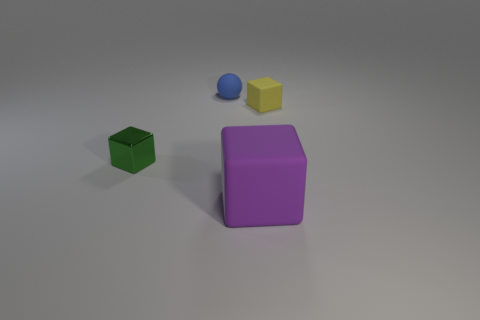There is a small thing in front of the yellow block; is there a tiny green shiny thing left of it?
Your answer should be very brief. No. What number of matte objects are either small objects or blue balls?
Ensure brevity in your answer.  2. The object that is in front of the rubber ball and behind the small green cube is made of what material?
Your response must be concise. Rubber. There is a tiny object that is in front of the block behind the metal cube; is there a big purple rubber block behind it?
Offer a very short reply. No. Are there any other things that have the same material as the purple cube?
Your response must be concise. Yes. The yellow object that is made of the same material as the large cube is what shape?
Provide a short and direct response. Cube. Is the number of tiny spheres that are behind the blue thing less than the number of large purple rubber things that are right of the large purple block?
Offer a terse response. No. How many tiny things are either blue things or yellow rubber blocks?
Your response must be concise. 2. There is a object behind the yellow cube; is its shape the same as the thing that is in front of the shiny cube?
Offer a terse response. No. There is a object that is to the left of the small rubber thing on the left side of the block that is in front of the metal object; what is its size?
Provide a succinct answer. Small. 